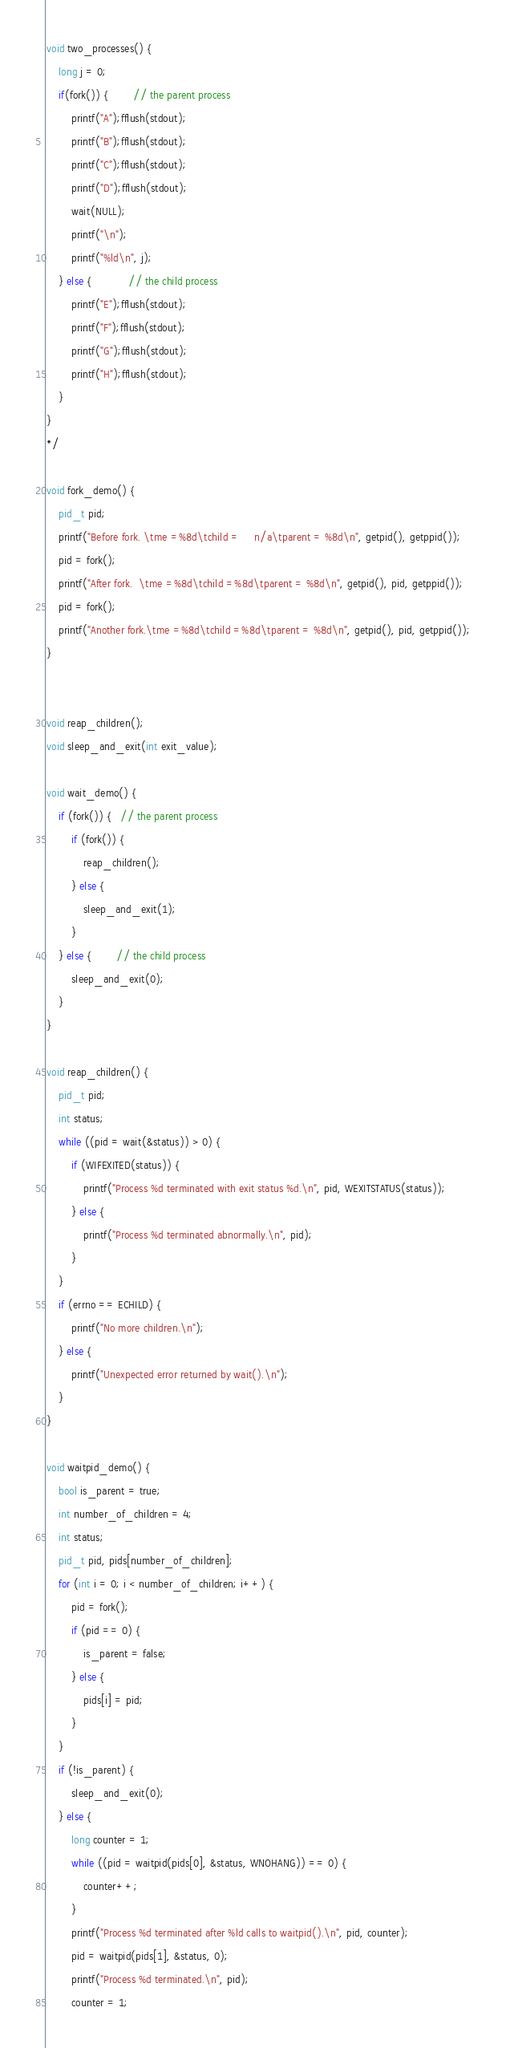<code> <loc_0><loc_0><loc_500><loc_500><_C_>void two_processes() {
    long j = 0;
    if(fork()) {        // the parent process
        printf("A");fflush(stdout);
        printf("B");fflush(stdout);
        printf("C");fflush(stdout);
        printf("D");fflush(stdout);
        wait(NULL);
        printf("\n");
        printf("%ld\n", j);
    } else {            // the child process
        printf("E");fflush(stdout);
        printf("F");fflush(stdout);
        printf("G");fflush(stdout);
        printf("H");fflush(stdout);
    }
}
*/

void fork_demo() {
    pid_t pid;
    printf("Before fork. \tme =%8d\tchild =     n/a\tparent = %8d\n", getpid(), getppid());
    pid = fork();
    printf("After fork.  \tme =%8d\tchild =%8d\tparent = %8d\n", getpid(), pid, getppid());
    pid = fork();
    printf("Another fork.\tme =%8d\tchild =%8d\tparent = %8d\n", getpid(), pid, getppid());
}


void reap_children();
void sleep_and_exit(int exit_value);

void wait_demo() {
    if (fork()) {   // the parent process
        if (fork()) {
            reap_children();
        } else {
            sleep_and_exit(1);
        }
    } else {        // the child process
        sleep_and_exit(0);
    }
}

void reap_children() {
    pid_t pid;
    int status;
    while ((pid = wait(&status)) > 0) {
        if (WIFEXITED(status)) {
            printf("Process %d terminated with exit status %d.\n", pid, WEXITSTATUS(status));
        } else {
            printf("Process %d terminated abnormally.\n", pid);
        }
    }
    if (errno == ECHILD) {
        printf("No more children.\n");
    } else {
        printf("Unexpected error returned by wait().\n");
    }
}

void waitpid_demo() {
    bool is_parent = true;
    int number_of_children = 4;
    int status;
    pid_t pid, pids[number_of_children];
    for (int i = 0; i < number_of_children; i++) {
        pid = fork();
        if (pid == 0) {
            is_parent = false;
        } else {
            pids[i] = pid;
        }
    }
    if (!is_parent) {
        sleep_and_exit(0);
    } else {
        long counter = 1;
        while ((pid = waitpid(pids[0], &status, WNOHANG)) == 0) {
            counter++;
        }
        printf("Process %d terminated after %ld calls to waitpid().\n", pid, counter);
        pid = waitpid(pids[1], &status, 0);
        printf("Process %d terminated.\n", pid);
        counter = 1;</code> 